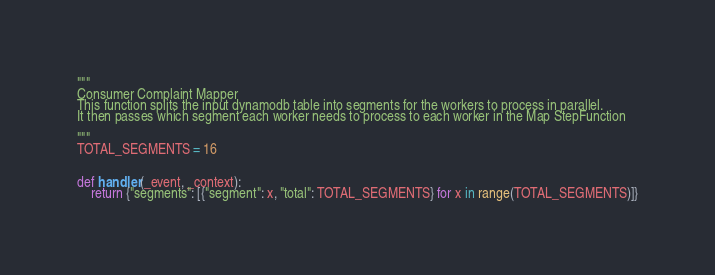Convert code to text. <code><loc_0><loc_0><loc_500><loc_500><_Python_>"""
Consumer Complaint Mapper
This function splits the input dynamodb table into segments for the workers to process in parallel.
It then passes which segment each worker needs to process to each worker in the Map StepFunction

"""
TOTAL_SEGMENTS = 16


def handler(_event, _context):
    return {"segments": [{"segment": x, "total": TOTAL_SEGMENTS} for x in range(TOTAL_SEGMENTS)]}
</code> 